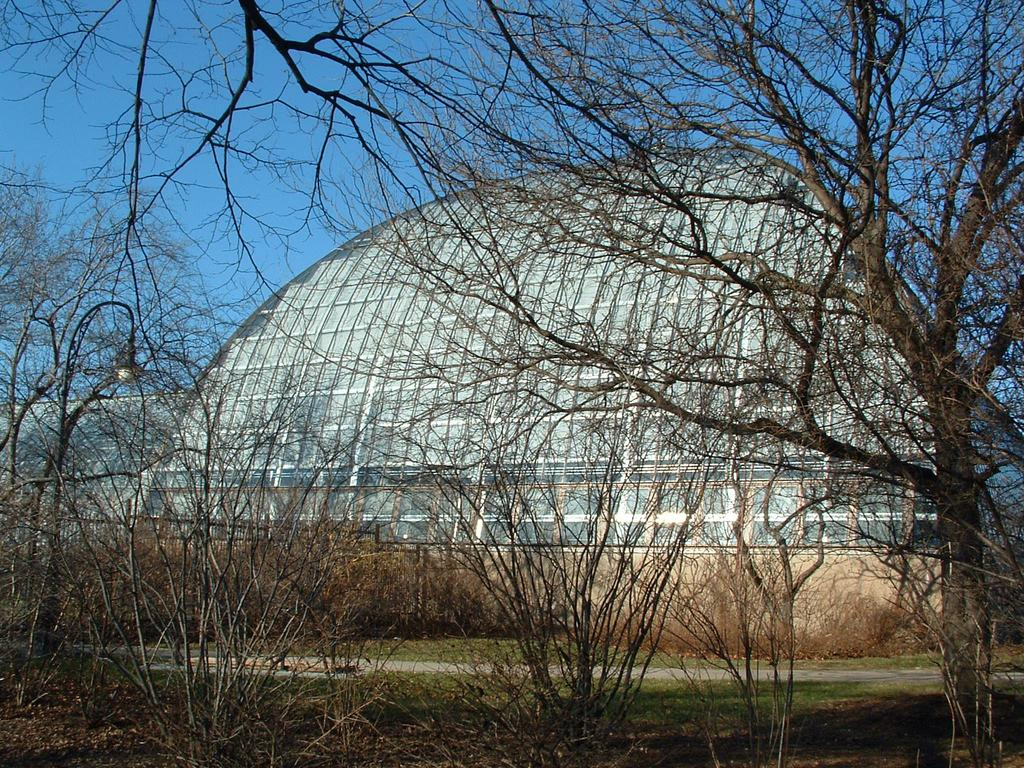What type of vegetation can be seen in the image? There are plants and trees in the image. What structure is present in the image that provides light? There is a light post in the image. What type of barrier is visible in the image? There is fencing in the image. What type of building is present in the image? There is a shed in the image. How many bottles can be seen on the ground in the image? There are no bottles present in the image. What type of terrain is visible in the image? The terrain is not specified in the image, but there are plants and trees, which suggest a natural setting. 